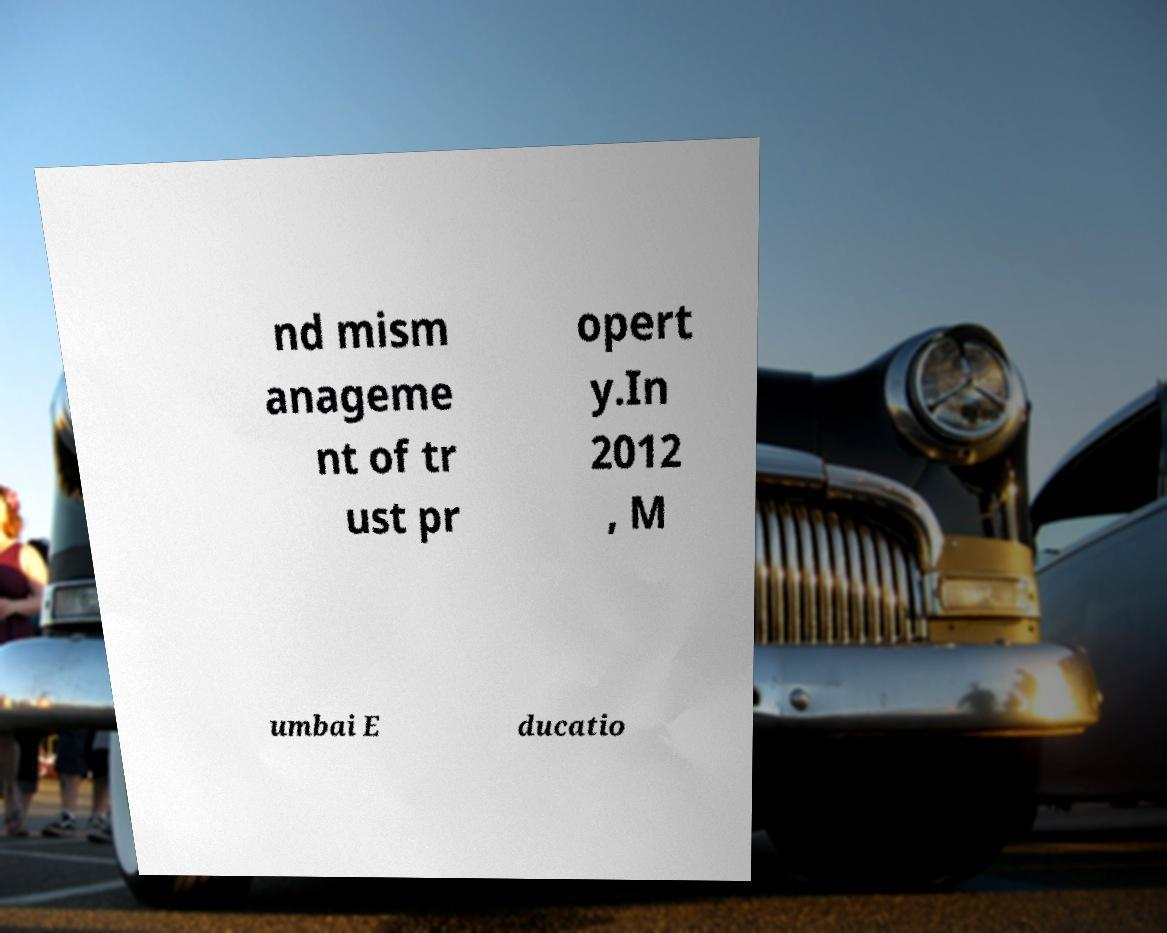There's text embedded in this image that I need extracted. Can you transcribe it verbatim? nd mism anageme nt of tr ust pr opert y.In 2012 , M umbai E ducatio 